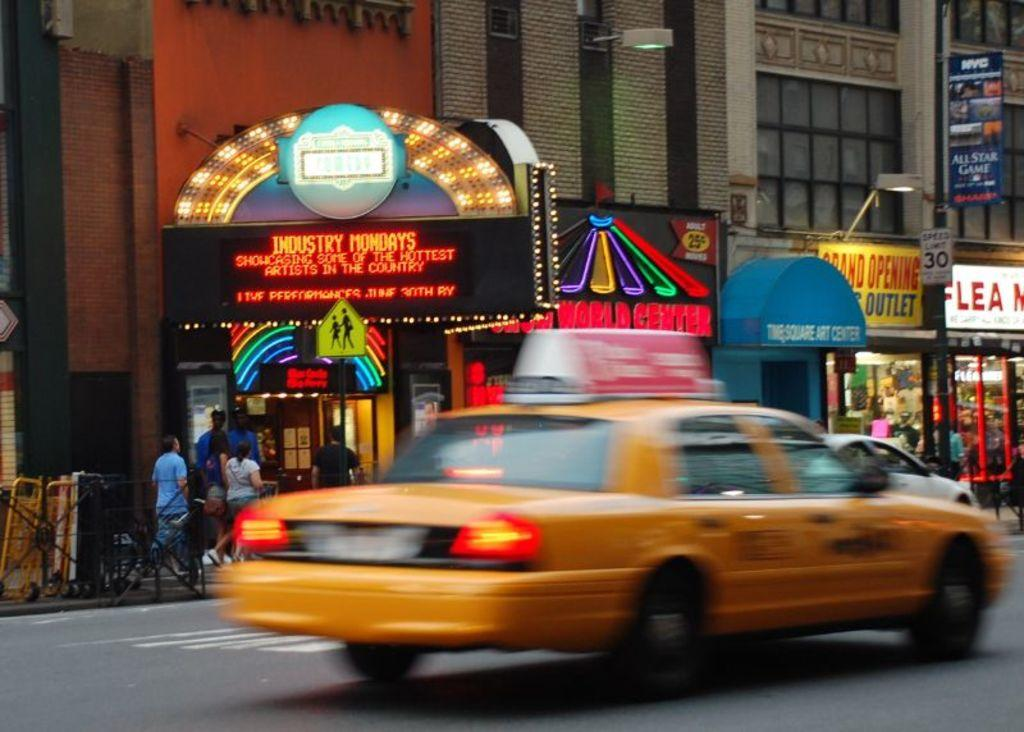<image>
Render a clear and concise summary of the photo. a taxi next to an area that says Mondays on it 